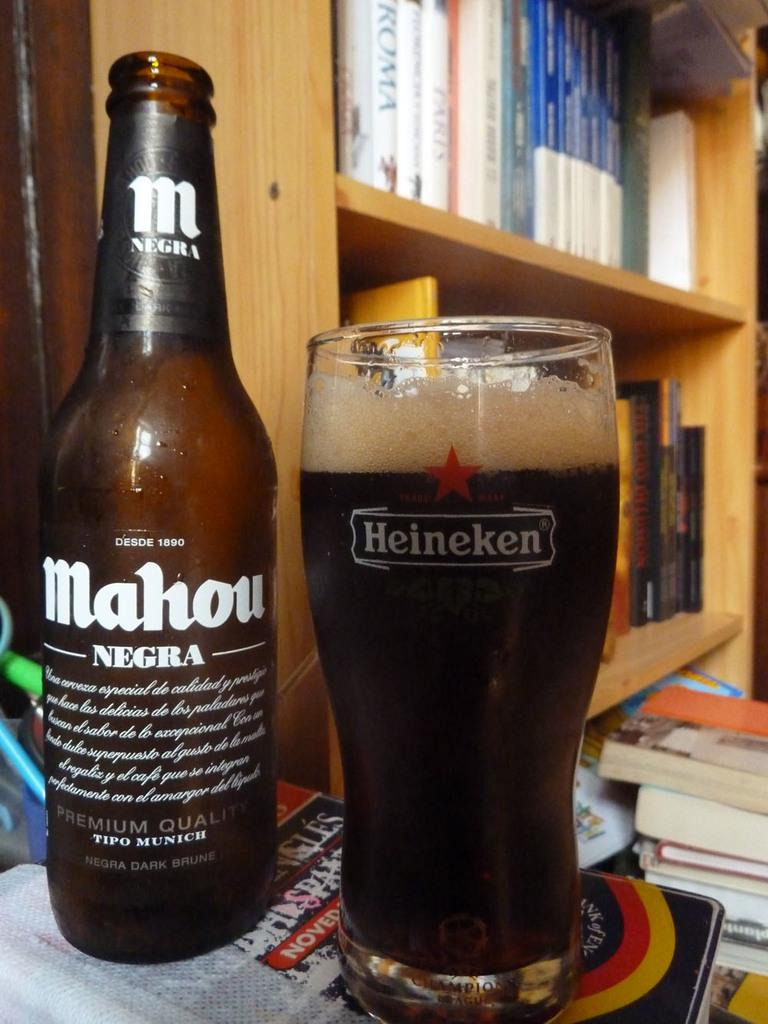<image>
Share a concise interpretation of the image provided. Bottle of Mahou Negra next to a cup that says Heineken. 